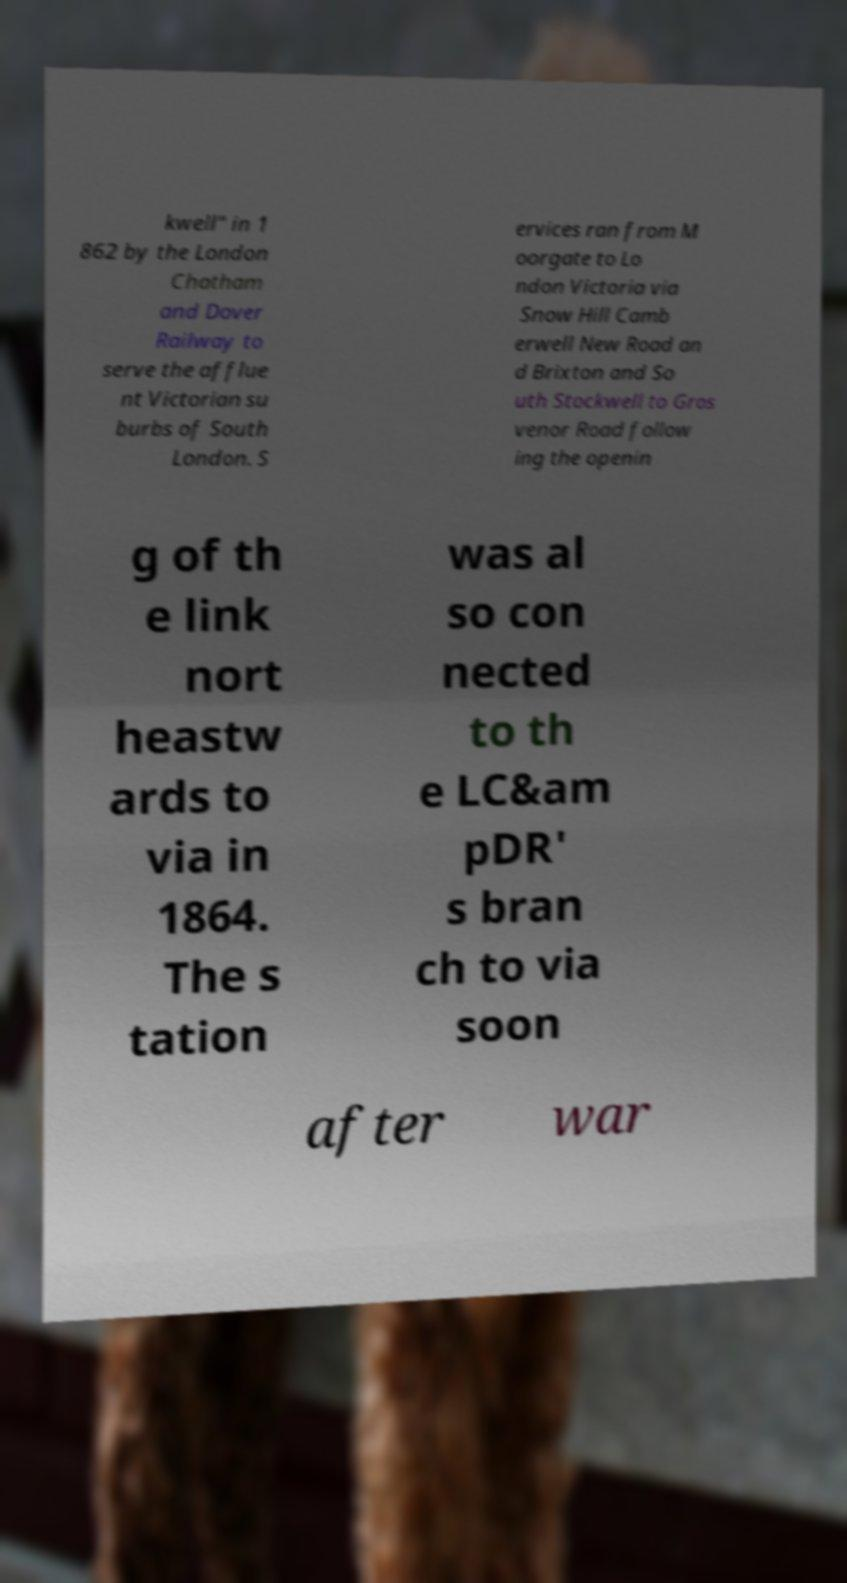Could you assist in decoding the text presented in this image and type it out clearly? kwell" in 1 862 by the London Chatham and Dover Railway to serve the afflue nt Victorian su burbs of South London. S ervices ran from M oorgate to Lo ndon Victoria via Snow Hill Camb erwell New Road an d Brixton and So uth Stockwell to Gros venor Road follow ing the openin g of th e link nort heastw ards to via in 1864. The s tation was al so con nected to th e LC&am pDR' s bran ch to via soon after war 